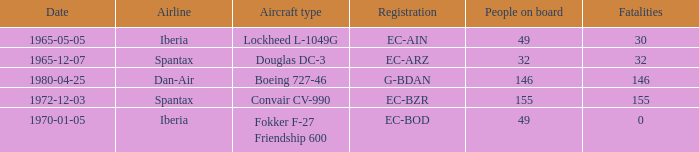How many fatalities are there for the airline of spantax, with a registration of ec-arz? 32.0. 